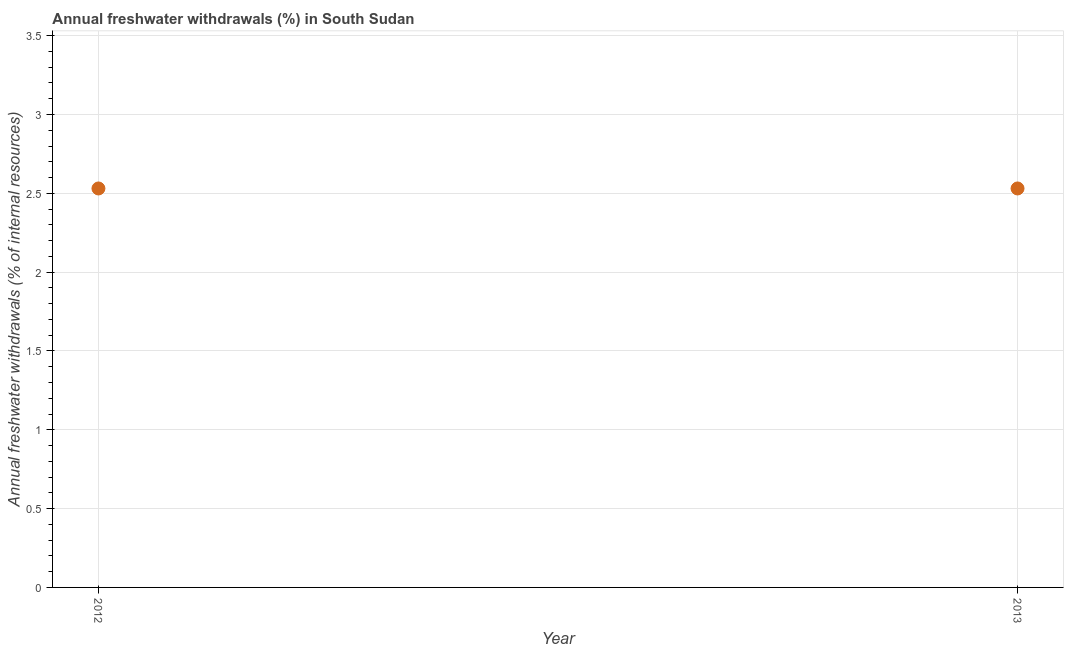What is the annual freshwater withdrawals in 2012?
Your answer should be very brief. 2.53. Across all years, what is the maximum annual freshwater withdrawals?
Your response must be concise. 2.53. Across all years, what is the minimum annual freshwater withdrawals?
Give a very brief answer. 2.53. In which year was the annual freshwater withdrawals maximum?
Give a very brief answer. 2012. What is the sum of the annual freshwater withdrawals?
Your answer should be very brief. 5.06. What is the difference between the annual freshwater withdrawals in 2012 and 2013?
Offer a very short reply. 0. What is the average annual freshwater withdrawals per year?
Ensure brevity in your answer.  2.53. What is the median annual freshwater withdrawals?
Offer a very short reply. 2.53. In how many years, is the annual freshwater withdrawals greater than 1.6 %?
Keep it short and to the point. 2. Is the annual freshwater withdrawals in 2012 less than that in 2013?
Your response must be concise. No. Does the annual freshwater withdrawals monotonically increase over the years?
Make the answer very short. No. What is the difference between two consecutive major ticks on the Y-axis?
Ensure brevity in your answer.  0.5. What is the title of the graph?
Offer a terse response. Annual freshwater withdrawals (%) in South Sudan. What is the label or title of the X-axis?
Offer a terse response. Year. What is the label or title of the Y-axis?
Ensure brevity in your answer.  Annual freshwater withdrawals (% of internal resources). What is the Annual freshwater withdrawals (% of internal resources) in 2012?
Make the answer very short. 2.53. What is the Annual freshwater withdrawals (% of internal resources) in 2013?
Your response must be concise. 2.53. What is the ratio of the Annual freshwater withdrawals (% of internal resources) in 2012 to that in 2013?
Ensure brevity in your answer.  1. 